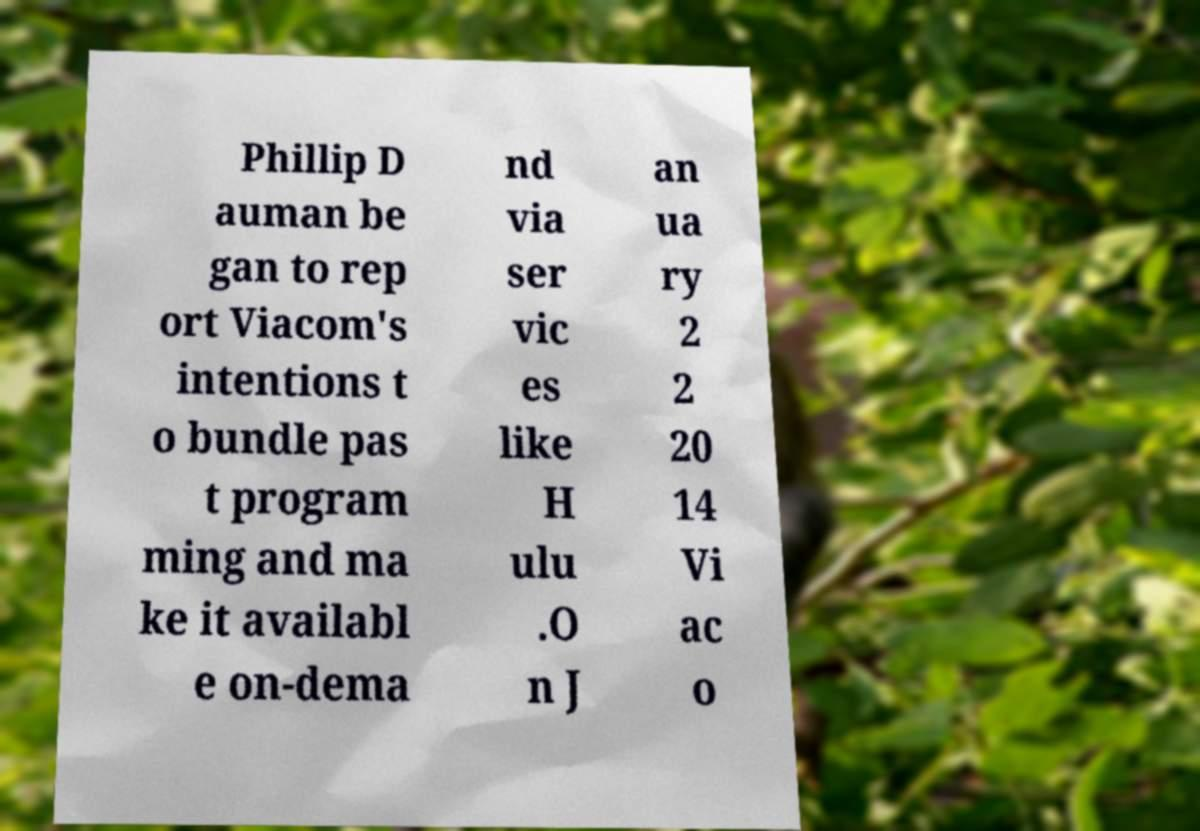There's text embedded in this image that I need extracted. Can you transcribe it verbatim? Phillip D auman be gan to rep ort Viacom's intentions t o bundle pas t program ming and ma ke it availabl e on-dema nd via ser vic es like H ulu .O n J an ua ry 2 2 20 14 Vi ac o 